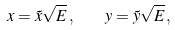<formula> <loc_0><loc_0><loc_500><loc_500>x = \tilde { x } \sqrt { E } \, , \quad y = \tilde { y } \sqrt { E } \, ,</formula> 